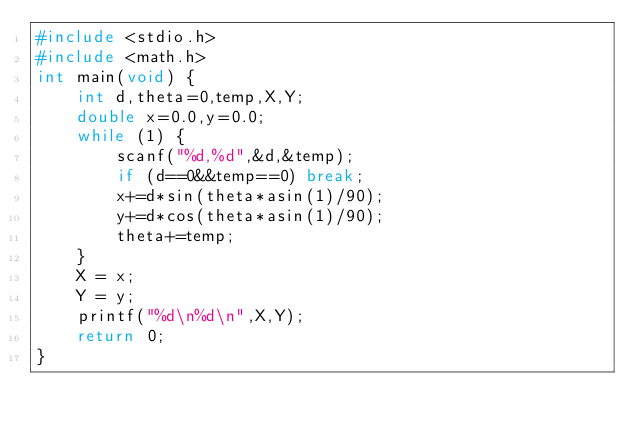<code> <loc_0><loc_0><loc_500><loc_500><_C_>#include <stdio.h>
#include <math.h>
int main(void) {
    int d,theta=0,temp,X,Y;
    double x=0.0,y=0.0;
    while (1) {
        scanf("%d,%d",&d,&temp);
        if (d==0&&temp==0) break;
        x+=d*sin(theta*asin(1)/90);
        y+=d*cos(theta*asin(1)/90);
        theta+=temp;
    }
    X = x;
    Y = y;
    printf("%d\n%d\n",X,Y);
    return 0;
}</code> 